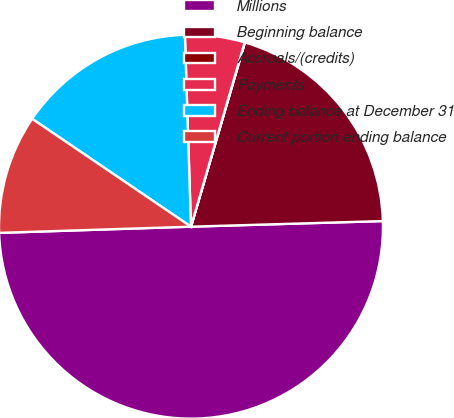Convert chart. <chart><loc_0><loc_0><loc_500><loc_500><pie_chart><fcel>Millions<fcel>Beginning balance<fcel>Accruals/(credits)<fcel>Payments<fcel>Ending balance at December 31<fcel>Current portion ending balance<nl><fcel>49.95%<fcel>20.0%<fcel>0.02%<fcel>5.02%<fcel>15.0%<fcel>10.01%<nl></chart> 